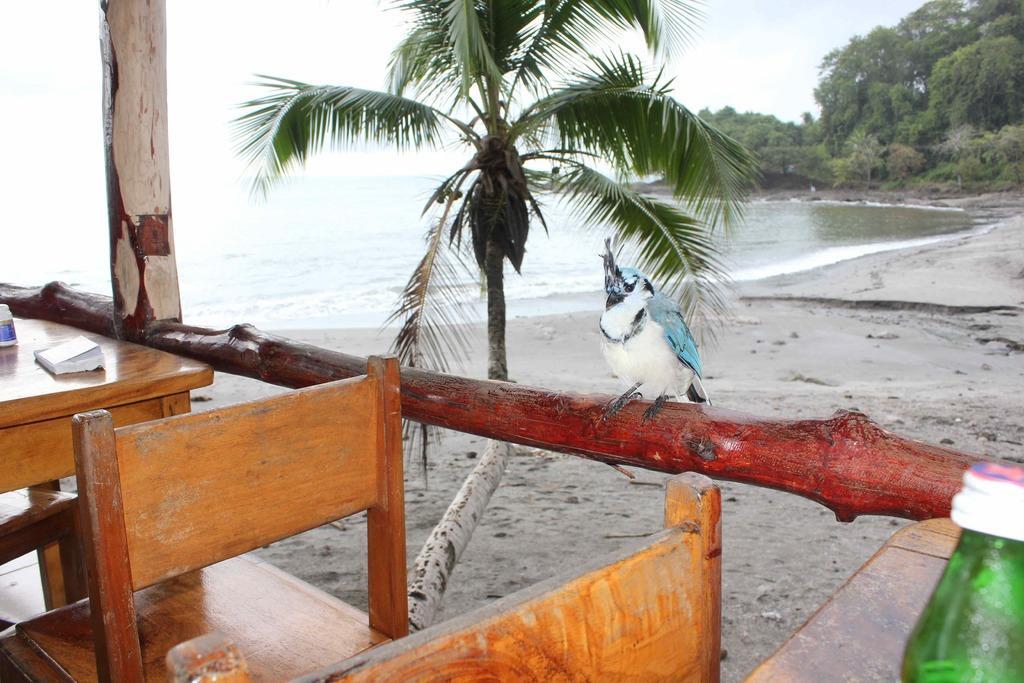Describe this image in one or two sentences. In this image, there is a table which is in yellow color, there are some chairs which are in yellow color, there is a bottle which is in green color kept on the table, there is a brown color bamboo, there is a bird sitting on the brown color bamboo, there is a green color plant, in the background there is a blue color sea and there are some green color trees and there is a sky in blue color. 